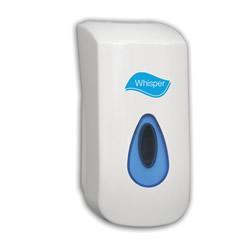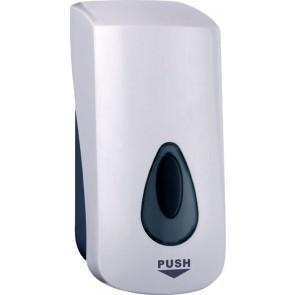The first image is the image on the left, the second image is the image on the right. Evaluate the accuracy of this statement regarding the images: "There are at least two dispensers in the image on the right.". Is it true? Answer yes or no. No. 